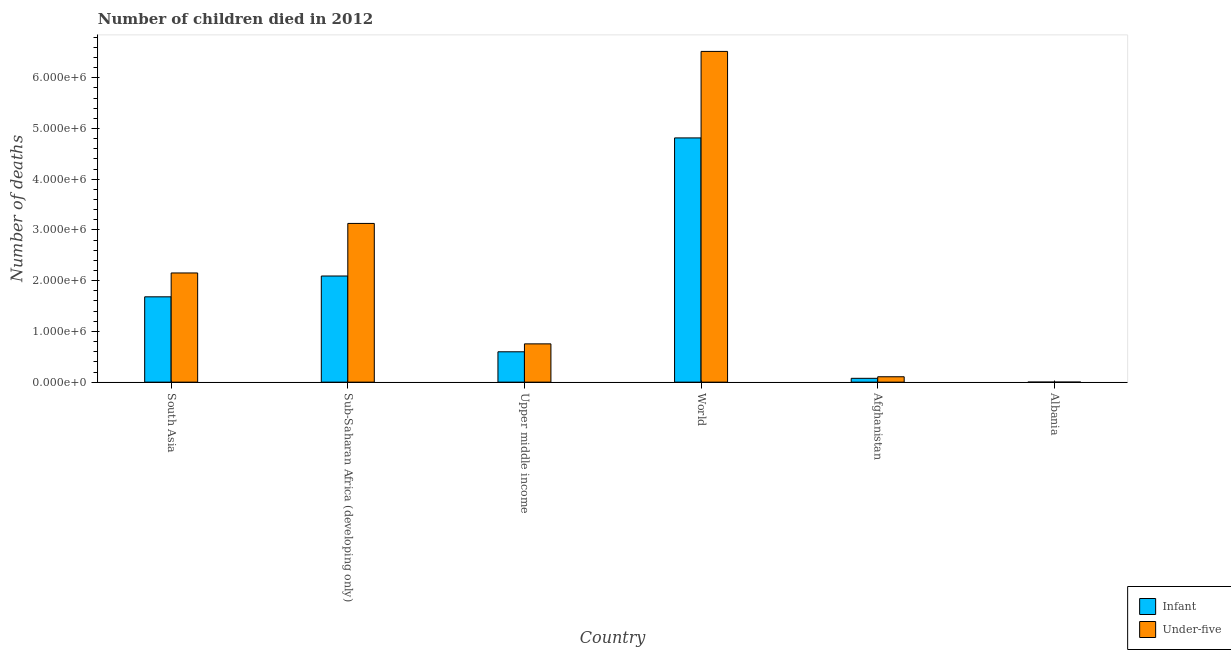Are the number of bars per tick equal to the number of legend labels?
Your answer should be very brief. Yes. How many bars are there on the 6th tick from the left?
Keep it short and to the point. 2. What is the number of infant deaths in Upper middle income?
Your answer should be compact. 5.99e+05. Across all countries, what is the maximum number of infant deaths?
Give a very brief answer. 4.81e+06. Across all countries, what is the minimum number of infant deaths?
Your answer should be very brief. 513. In which country was the number of infant deaths minimum?
Provide a succinct answer. Albania. What is the total number of under-five deaths in the graph?
Give a very brief answer. 1.27e+07. What is the difference between the number of under-five deaths in Afghanistan and that in Upper middle income?
Give a very brief answer. -6.48e+05. What is the difference between the number of under-five deaths in Afghanistan and the number of infant deaths in Albania?
Offer a very short reply. 1.06e+05. What is the average number of infant deaths per country?
Offer a terse response. 1.54e+06. What is the difference between the number of under-five deaths and number of infant deaths in Upper middle income?
Your answer should be compact. 1.56e+05. What is the ratio of the number of infant deaths in Upper middle income to that in World?
Provide a short and direct response. 0.12. Is the difference between the number of infant deaths in Albania and South Asia greater than the difference between the number of under-five deaths in Albania and South Asia?
Provide a short and direct response. Yes. What is the difference between the highest and the second highest number of under-five deaths?
Provide a short and direct response. 3.39e+06. What is the difference between the highest and the lowest number of under-five deaths?
Offer a terse response. 6.52e+06. What does the 2nd bar from the left in Upper middle income represents?
Provide a succinct answer. Under-five. What does the 2nd bar from the right in Albania represents?
Give a very brief answer. Infant. Are the values on the major ticks of Y-axis written in scientific E-notation?
Make the answer very short. Yes. Does the graph contain grids?
Your answer should be compact. No. How are the legend labels stacked?
Keep it short and to the point. Vertical. What is the title of the graph?
Provide a succinct answer. Number of children died in 2012. What is the label or title of the X-axis?
Offer a terse response. Country. What is the label or title of the Y-axis?
Ensure brevity in your answer.  Number of deaths. What is the Number of deaths of Infant in South Asia?
Your answer should be compact. 1.68e+06. What is the Number of deaths of Under-five in South Asia?
Provide a succinct answer. 2.15e+06. What is the Number of deaths in Infant in Sub-Saharan Africa (developing only)?
Keep it short and to the point. 2.09e+06. What is the Number of deaths of Under-five in Sub-Saharan Africa (developing only)?
Keep it short and to the point. 3.13e+06. What is the Number of deaths of Infant in Upper middle income?
Offer a very short reply. 5.99e+05. What is the Number of deaths of Under-five in Upper middle income?
Your answer should be very brief. 7.55e+05. What is the Number of deaths of Infant in World?
Keep it short and to the point. 4.81e+06. What is the Number of deaths in Under-five in World?
Your answer should be very brief. 6.52e+06. What is the Number of deaths in Infant in Afghanistan?
Offer a terse response. 7.56e+04. What is the Number of deaths in Under-five in Afghanistan?
Your response must be concise. 1.06e+05. What is the Number of deaths of Infant in Albania?
Give a very brief answer. 513. What is the Number of deaths in Under-five in Albania?
Give a very brief answer. 567. Across all countries, what is the maximum Number of deaths of Infant?
Your answer should be compact. 4.81e+06. Across all countries, what is the maximum Number of deaths of Under-five?
Ensure brevity in your answer.  6.52e+06. Across all countries, what is the minimum Number of deaths in Infant?
Ensure brevity in your answer.  513. Across all countries, what is the minimum Number of deaths in Under-five?
Make the answer very short. 567. What is the total Number of deaths in Infant in the graph?
Your answer should be very brief. 9.26e+06. What is the total Number of deaths in Under-five in the graph?
Your answer should be very brief. 1.27e+07. What is the difference between the Number of deaths of Infant in South Asia and that in Sub-Saharan Africa (developing only)?
Your response must be concise. -4.10e+05. What is the difference between the Number of deaths of Under-five in South Asia and that in Sub-Saharan Africa (developing only)?
Keep it short and to the point. -9.76e+05. What is the difference between the Number of deaths in Infant in South Asia and that in Upper middle income?
Offer a very short reply. 1.08e+06. What is the difference between the Number of deaths of Under-five in South Asia and that in Upper middle income?
Your response must be concise. 1.40e+06. What is the difference between the Number of deaths of Infant in South Asia and that in World?
Your response must be concise. -3.13e+06. What is the difference between the Number of deaths of Under-five in South Asia and that in World?
Give a very brief answer. -4.37e+06. What is the difference between the Number of deaths in Infant in South Asia and that in Afghanistan?
Your answer should be compact. 1.61e+06. What is the difference between the Number of deaths of Under-five in South Asia and that in Afghanistan?
Give a very brief answer. 2.05e+06. What is the difference between the Number of deaths in Infant in South Asia and that in Albania?
Your response must be concise. 1.68e+06. What is the difference between the Number of deaths of Under-five in South Asia and that in Albania?
Your response must be concise. 2.15e+06. What is the difference between the Number of deaths in Infant in Sub-Saharan Africa (developing only) and that in Upper middle income?
Your response must be concise. 1.49e+06. What is the difference between the Number of deaths of Under-five in Sub-Saharan Africa (developing only) and that in Upper middle income?
Give a very brief answer. 2.37e+06. What is the difference between the Number of deaths of Infant in Sub-Saharan Africa (developing only) and that in World?
Give a very brief answer. -2.72e+06. What is the difference between the Number of deaths of Under-five in Sub-Saharan Africa (developing only) and that in World?
Offer a terse response. -3.39e+06. What is the difference between the Number of deaths in Infant in Sub-Saharan Africa (developing only) and that in Afghanistan?
Your answer should be compact. 2.02e+06. What is the difference between the Number of deaths of Under-five in Sub-Saharan Africa (developing only) and that in Afghanistan?
Offer a terse response. 3.02e+06. What is the difference between the Number of deaths of Infant in Sub-Saharan Africa (developing only) and that in Albania?
Make the answer very short. 2.09e+06. What is the difference between the Number of deaths in Under-five in Sub-Saharan Africa (developing only) and that in Albania?
Your response must be concise. 3.13e+06. What is the difference between the Number of deaths of Infant in Upper middle income and that in World?
Your answer should be compact. -4.22e+06. What is the difference between the Number of deaths in Under-five in Upper middle income and that in World?
Your answer should be compact. -5.77e+06. What is the difference between the Number of deaths in Infant in Upper middle income and that in Afghanistan?
Give a very brief answer. 5.23e+05. What is the difference between the Number of deaths of Under-five in Upper middle income and that in Afghanistan?
Make the answer very short. 6.48e+05. What is the difference between the Number of deaths in Infant in Upper middle income and that in Albania?
Offer a terse response. 5.98e+05. What is the difference between the Number of deaths of Under-five in Upper middle income and that in Albania?
Provide a succinct answer. 7.54e+05. What is the difference between the Number of deaths in Infant in World and that in Afghanistan?
Your answer should be very brief. 4.74e+06. What is the difference between the Number of deaths in Under-five in World and that in Afghanistan?
Your answer should be compact. 6.41e+06. What is the difference between the Number of deaths in Infant in World and that in Albania?
Keep it short and to the point. 4.81e+06. What is the difference between the Number of deaths in Under-five in World and that in Albania?
Keep it short and to the point. 6.52e+06. What is the difference between the Number of deaths in Infant in Afghanistan and that in Albania?
Your answer should be very brief. 7.51e+04. What is the difference between the Number of deaths of Under-five in Afghanistan and that in Albania?
Your answer should be very brief. 1.06e+05. What is the difference between the Number of deaths in Infant in South Asia and the Number of deaths in Under-five in Sub-Saharan Africa (developing only)?
Keep it short and to the point. -1.45e+06. What is the difference between the Number of deaths of Infant in South Asia and the Number of deaths of Under-five in Upper middle income?
Offer a very short reply. 9.28e+05. What is the difference between the Number of deaths in Infant in South Asia and the Number of deaths in Under-five in World?
Ensure brevity in your answer.  -4.84e+06. What is the difference between the Number of deaths in Infant in South Asia and the Number of deaths in Under-five in Afghanistan?
Your response must be concise. 1.58e+06. What is the difference between the Number of deaths in Infant in South Asia and the Number of deaths in Under-five in Albania?
Your answer should be very brief. 1.68e+06. What is the difference between the Number of deaths in Infant in Sub-Saharan Africa (developing only) and the Number of deaths in Under-five in Upper middle income?
Your answer should be compact. 1.34e+06. What is the difference between the Number of deaths of Infant in Sub-Saharan Africa (developing only) and the Number of deaths of Under-five in World?
Ensure brevity in your answer.  -4.43e+06. What is the difference between the Number of deaths in Infant in Sub-Saharan Africa (developing only) and the Number of deaths in Under-five in Afghanistan?
Your answer should be very brief. 1.99e+06. What is the difference between the Number of deaths in Infant in Sub-Saharan Africa (developing only) and the Number of deaths in Under-five in Albania?
Give a very brief answer. 2.09e+06. What is the difference between the Number of deaths in Infant in Upper middle income and the Number of deaths in Under-five in World?
Your answer should be very brief. -5.92e+06. What is the difference between the Number of deaths of Infant in Upper middle income and the Number of deaths of Under-five in Afghanistan?
Provide a succinct answer. 4.92e+05. What is the difference between the Number of deaths in Infant in Upper middle income and the Number of deaths in Under-five in Albania?
Offer a terse response. 5.98e+05. What is the difference between the Number of deaths in Infant in World and the Number of deaths in Under-five in Afghanistan?
Keep it short and to the point. 4.71e+06. What is the difference between the Number of deaths in Infant in World and the Number of deaths in Under-five in Albania?
Offer a very short reply. 4.81e+06. What is the difference between the Number of deaths in Infant in Afghanistan and the Number of deaths in Under-five in Albania?
Keep it short and to the point. 7.50e+04. What is the average Number of deaths of Infant per country?
Offer a very short reply. 1.54e+06. What is the average Number of deaths of Under-five per country?
Offer a terse response. 2.11e+06. What is the difference between the Number of deaths in Infant and Number of deaths in Under-five in South Asia?
Your answer should be compact. -4.70e+05. What is the difference between the Number of deaths of Infant and Number of deaths of Under-five in Sub-Saharan Africa (developing only)?
Offer a terse response. -1.04e+06. What is the difference between the Number of deaths in Infant and Number of deaths in Under-five in Upper middle income?
Offer a very short reply. -1.56e+05. What is the difference between the Number of deaths in Infant and Number of deaths in Under-five in World?
Your answer should be very brief. -1.71e+06. What is the difference between the Number of deaths of Infant and Number of deaths of Under-five in Afghanistan?
Your response must be concise. -3.06e+04. What is the difference between the Number of deaths of Infant and Number of deaths of Under-five in Albania?
Your answer should be very brief. -54. What is the ratio of the Number of deaths of Infant in South Asia to that in Sub-Saharan Africa (developing only)?
Provide a short and direct response. 0.8. What is the ratio of the Number of deaths of Under-five in South Asia to that in Sub-Saharan Africa (developing only)?
Make the answer very short. 0.69. What is the ratio of the Number of deaths in Infant in South Asia to that in Upper middle income?
Offer a terse response. 2.81. What is the ratio of the Number of deaths of Under-five in South Asia to that in Upper middle income?
Provide a short and direct response. 2.85. What is the ratio of the Number of deaths in Infant in South Asia to that in World?
Your answer should be compact. 0.35. What is the ratio of the Number of deaths of Under-five in South Asia to that in World?
Provide a short and direct response. 0.33. What is the ratio of the Number of deaths in Infant in South Asia to that in Afghanistan?
Provide a succinct answer. 22.26. What is the ratio of the Number of deaths of Under-five in South Asia to that in Afghanistan?
Offer a very short reply. 20.27. What is the ratio of the Number of deaths in Infant in South Asia to that in Albania?
Your answer should be very brief. 3279.16. What is the ratio of the Number of deaths of Under-five in South Asia to that in Albania?
Provide a short and direct response. 3796.33. What is the ratio of the Number of deaths of Infant in Sub-Saharan Africa (developing only) to that in Upper middle income?
Keep it short and to the point. 3.5. What is the ratio of the Number of deaths of Under-five in Sub-Saharan Africa (developing only) to that in Upper middle income?
Your answer should be very brief. 4.15. What is the ratio of the Number of deaths in Infant in Sub-Saharan Africa (developing only) to that in World?
Give a very brief answer. 0.43. What is the ratio of the Number of deaths of Under-five in Sub-Saharan Africa (developing only) to that in World?
Offer a terse response. 0.48. What is the ratio of the Number of deaths in Infant in Sub-Saharan Africa (developing only) to that in Afghanistan?
Give a very brief answer. 27.68. What is the ratio of the Number of deaths in Under-five in Sub-Saharan Africa (developing only) to that in Afghanistan?
Keep it short and to the point. 29.46. What is the ratio of the Number of deaths of Infant in Sub-Saharan Africa (developing only) to that in Albania?
Offer a terse response. 4078.96. What is the ratio of the Number of deaths of Under-five in Sub-Saharan Africa (developing only) to that in Albania?
Offer a very short reply. 5518.3. What is the ratio of the Number of deaths of Infant in Upper middle income to that in World?
Provide a short and direct response. 0.12. What is the ratio of the Number of deaths in Under-five in Upper middle income to that in World?
Your response must be concise. 0.12. What is the ratio of the Number of deaths of Infant in Upper middle income to that in Afghanistan?
Ensure brevity in your answer.  7.92. What is the ratio of the Number of deaths of Under-five in Upper middle income to that in Afghanistan?
Give a very brief answer. 7.1. What is the ratio of the Number of deaths in Infant in Upper middle income to that in Albania?
Your response must be concise. 1166.74. What is the ratio of the Number of deaths of Under-five in Upper middle income to that in Albania?
Your answer should be compact. 1330.82. What is the ratio of the Number of deaths in Infant in World to that in Afghanistan?
Keep it short and to the point. 63.7. What is the ratio of the Number of deaths in Under-five in World to that in Afghanistan?
Give a very brief answer. 61.38. What is the ratio of the Number of deaths in Infant in World to that in Albania?
Your answer should be very brief. 9385.52. What is the ratio of the Number of deaths of Under-five in World to that in Albania?
Provide a succinct answer. 1.15e+04. What is the ratio of the Number of deaths in Infant in Afghanistan to that in Albania?
Make the answer very short. 147.34. What is the ratio of the Number of deaths of Under-five in Afghanistan to that in Albania?
Ensure brevity in your answer.  187.33. What is the difference between the highest and the second highest Number of deaths in Infant?
Your answer should be very brief. 2.72e+06. What is the difference between the highest and the second highest Number of deaths in Under-five?
Your answer should be very brief. 3.39e+06. What is the difference between the highest and the lowest Number of deaths in Infant?
Give a very brief answer. 4.81e+06. What is the difference between the highest and the lowest Number of deaths of Under-five?
Keep it short and to the point. 6.52e+06. 